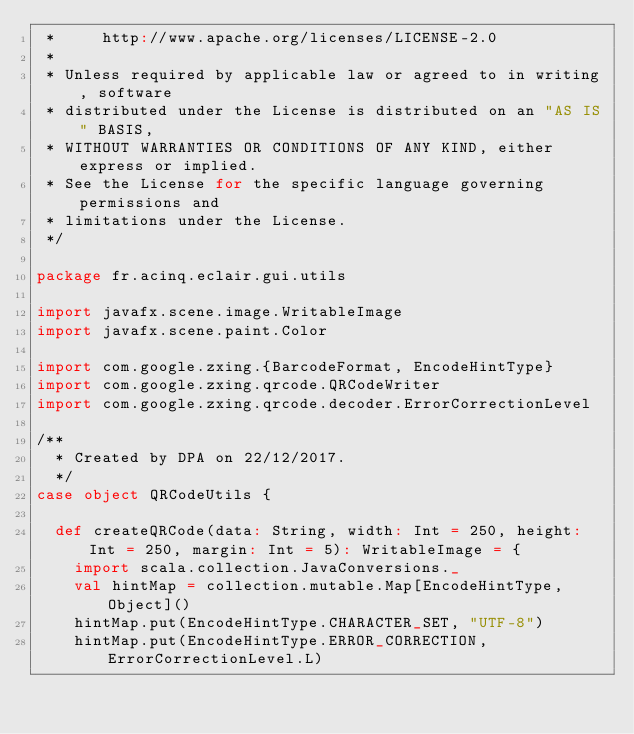<code> <loc_0><loc_0><loc_500><loc_500><_Scala_> *     http://www.apache.org/licenses/LICENSE-2.0
 *
 * Unless required by applicable law or agreed to in writing, software
 * distributed under the License is distributed on an "AS IS" BASIS,
 * WITHOUT WARRANTIES OR CONDITIONS OF ANY KIND, either express or implied.
 * See the License for the specific language governing permissions and
 * limitations under the License.
 */

package fr.acinq.eclair.gui.utils

import javafx.scene.image.WritableImage
import javafx.scene.paint.Color

import com.google.zxing.{BarcodeFormat, EncodeHintType}
import com.google.zxing.qrcode.QRCodeWriter
import com.google.zxing.qrcode.decoder.ErrorCorrectionLevel

/**
  * Created by DPA on 22/12/2017.
  */
case object QRCodeUtils {

  def createQRCode(data: String, width: Int = 250, height: Int = 250, margin: Int = 5): WritableImage = {
    import scala.collection.JavaConversions._
    val hintMap = collection.mutable.Map[EncodeHintType, Object]()
    hintMap.put(EncodeHintType.CHARACTER_SET, "UTF-8")
    hintMap.put(EncodeHintType.ERROR_CORRECTION, ErrorCorrectionLevel.L)</code> 